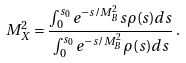Convert formula to latex. <formula><loc_0><loc_0><loc_500><loc_500>M ^ { 2 } _ { X } = \frac { \int ^ { s _ { 0 } } _ { 0 } e ^ { - s / M _ { B } ^ { 2 } } s \rho ( s ) d s } { \int ^ { s _ { 0 } } _ { 0 } e ^ { - s / M _ { B } ^ { 2 } } \rho ( s ) d s } \, .</formula> 